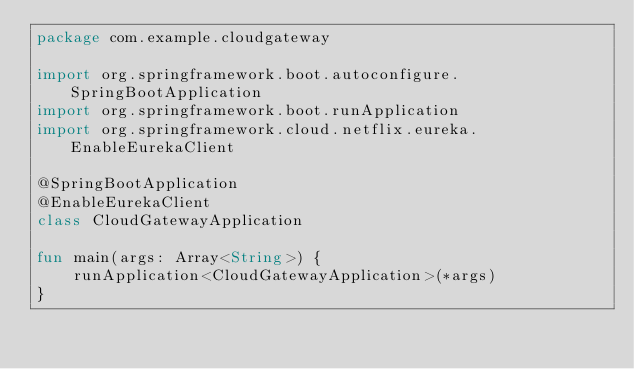<code> <loc_0><loc_0><loc_500><loc_500><_Kotlin_>package com.example.cloudgateway

import org.springframework.boot.autoconfigure.SpringBootApplication
import org.springframework.boot.runApplication
import org.springframework.cloud.netflix.eureka.EnableEurekaClient

@SpringBootApplication
@EnableEurekaClient
class CloudGatewayApplication

fun main(args: Array<String>) {
	runApplication<CloudGatewayApplication>(*args)
}
</code> 